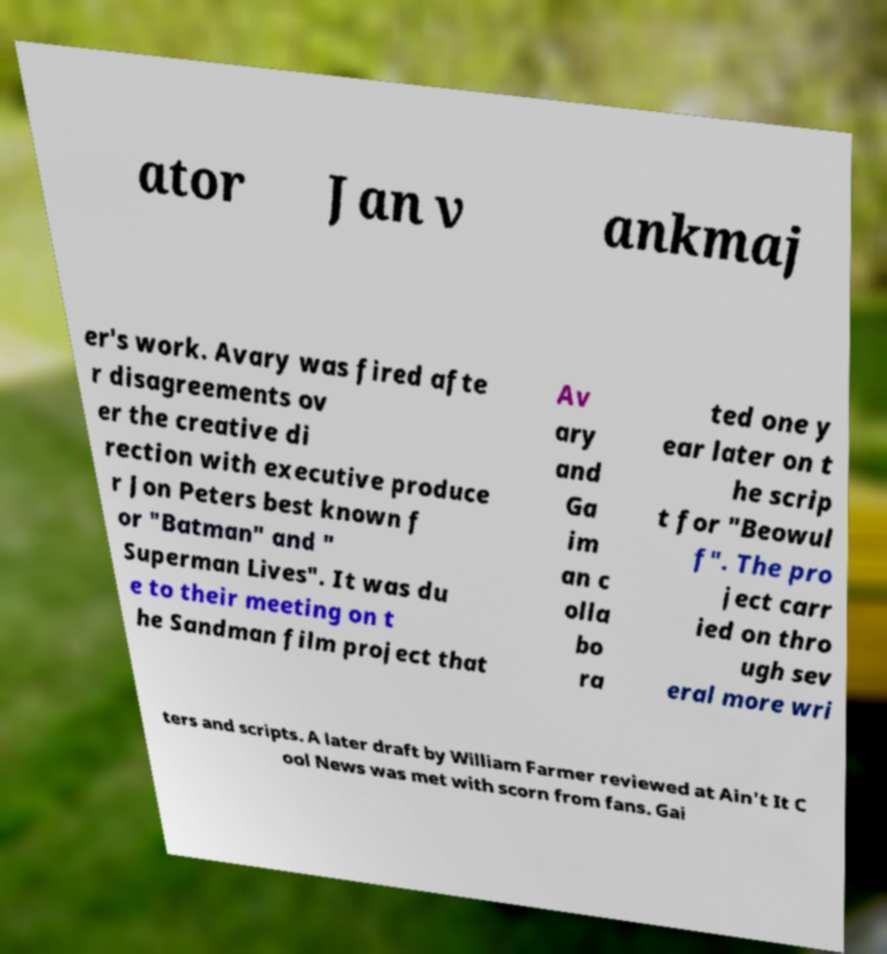I need the written content from this picture converted into text. Can you do that? ator Jan v ankmaj er's work. Avary was fired afte r disagreements ov er the creative di rection with executive produce r Jon Peters best known f or "Batman" and " Superman Lives". It was du e to their meeting on t he Sandman film project that Av ary and Ga im an c olla bo ra ted one y ear later on t he scrip t for "Beowul f". The pro ject carr ied on thro ugh sev eral more wri ters and scripts. A later draft by William Farmer reviewed at Ain't It C ool News was met with scorn from fans. Gai 